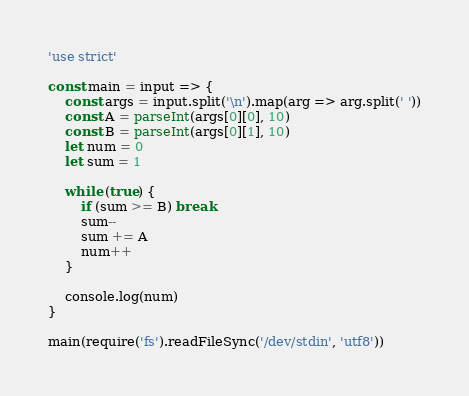Convert code to text. <code><loc_0><loc_0><loc_500><loc_500><_JavaScript_>'use strict'

const main = input => {
	const args = input.split('\n').map(arg => arg.split(' '))
	const A = parseInt(args[0][0], 10)
	const B = parseInt(args[0][1], 10)
	let num = 0
	let sum = 1

	while (true) {
		if (sum >= B) break
		sum--
		sum += A
		num++
	}

	console.log(num)
}

main(require('fs').readFileSync('/dev/stdin', 'utf8'))
</code> 